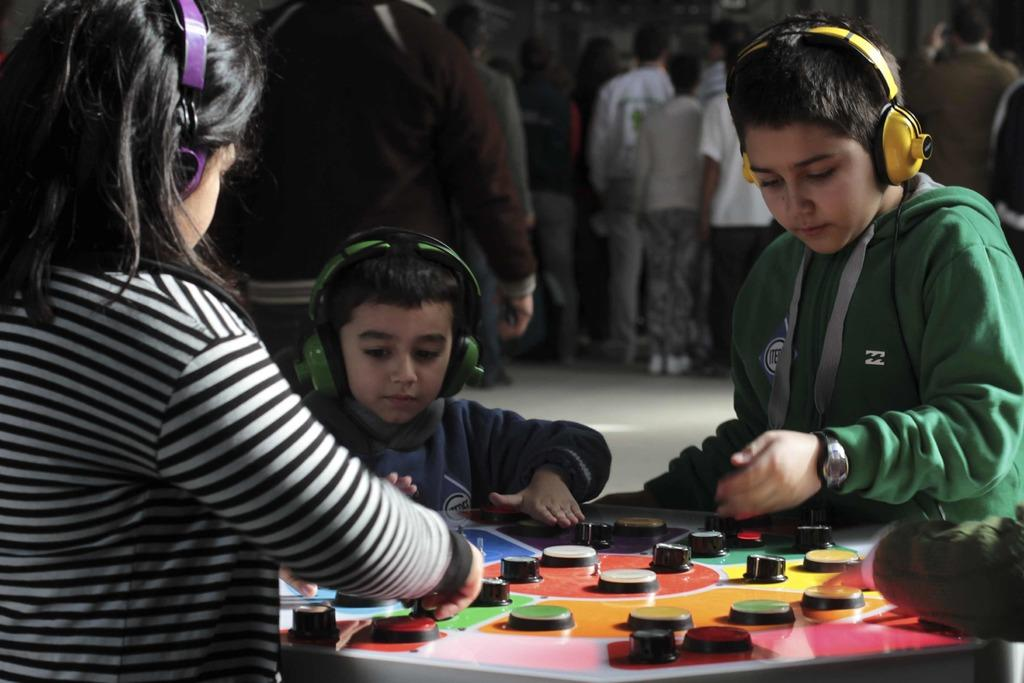What are the kids in the image doing? The kids in the image are playing a game. What are the kids wearing while playing the game? The kids are wearing headsets. Can you describe the people behind the kids in the image? There are other people behind the kids in the image. How many worms can be seen crawling on the ground in the image? There are no worms visible in the image. What is the increase in the number of horses in the image compared to the previous year? There are no horses present in the image, so it is not possible to determine any increase or decrease in their number. 